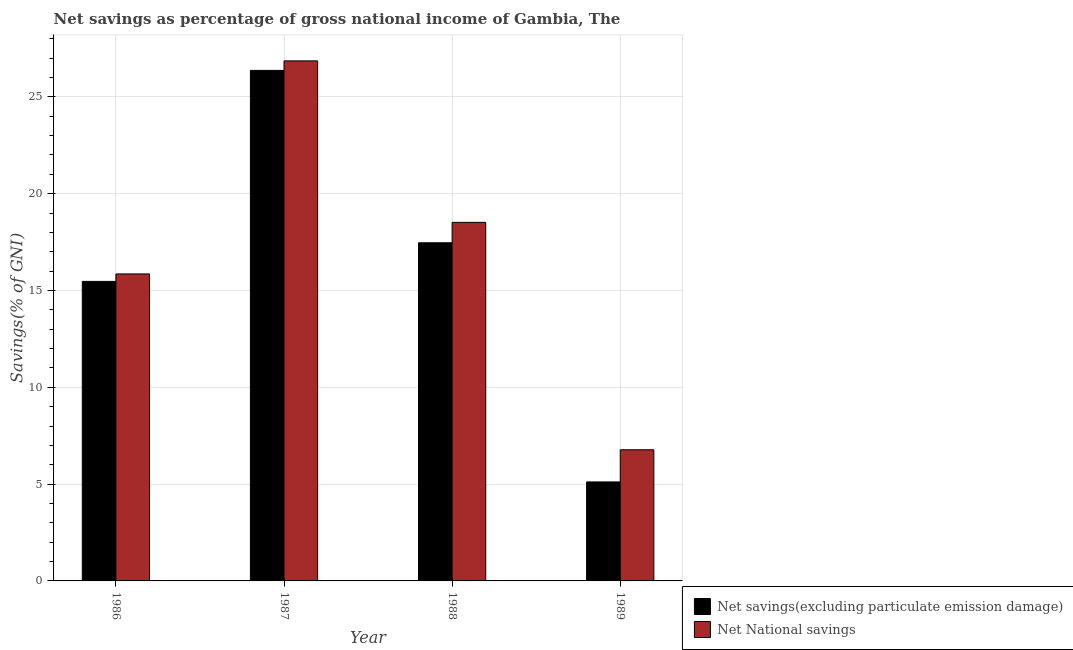Are the number of bars per tick equal to the number of legend labels?
Provide a short and direct response. Yes. Are the number of bars on each tick of the X-axis equal?
Give a very brief answer. Yes. How many bars are there on the 3rd tick from the right?
Offer a very short reply. 2. What is the net national savings in 1986?
Provide a succinct answer. 15.86. Across all years, what is the maximum net national savings?
Your response must be concise. 26.86. Across all years, what is the minimum net national savings?
Your answer should be compact. 6.77. In which year was the net national savings maximum?
Provide a succinct answer. 1987. In which year was the net national savings minimum?
Ensure brevity in your answer.  1989. What is the total net savings(excluding particulate emission damage) in the graph?
Your answer should be compact. 64.41. What is the difference between the net savings(excluding particulate emission damage) in 1986 and that in 1987?
Offer a terse response. -10.9. What is the difference between the net national savings in 1988 and the net savings(excluding particulate emission damage) in 1986?
Provide a short and direct response. 2.66. What is the average net savings(excluding particulate emission damage) per year?
Provide a succinct answer. 16.1. In the year 1989, what is the difference between the net savings(excluding particulate emission damage) and net national savings?
Provide a short and direct response. 0. In how many years, is the net national savings greater than 19 %?
Keep it short and to the point. 1. What is the ratio of the net national savings in 1988 to that in 1989?
Offer a terse response. 2.73. Is the net national savings in 1987 less than that in 1988?
Your answer should be very brief. No. What is the difference between the highest and the second highest net savings(excluding particulate emission damage)?
Give a very brief answer. 8.9. What is the difference between the highest and the lowest net national savings?
Offer a very short reply. 20.08. In how many years, is the net national savings greater than the average net national savings taken over all years?
Provide a succinct answer. 2. Is the sum of the net savings(excluding particulate emission damage) in 1988 and 1989 greater than the maximum net national savings across all years?
Provide a succinct answer. No. What does the 1st bar from the left in 1988 represents?
Give a very brief answer. Net savings(excluding particulate emission damage). What does the 1st bar from the right in 1987 represents?
Give a very brief answer. Net National savings. Are all the bars in the graph horizontal?
Ensure brevity in your answer.  No. Does the graph contain any zero values?
Give a very brief answer. No. Does the graph contain grids?
Ensure brevity in your answer.  Yes. Where does the legend appear in the graph?
Make the answer very short. Bottom right. How are the legend labels stacked?
Keep it short and to the point. Vertical. What is the title of the graph?
Ensure brevity in your answer.  Net savings as percentage of gross national income of Gambia, The. Does "Male labor force" appear as one of the legend labels in the graph?
Provide a short and direct response. No. What is the label or title of the X-axis?
Make the answer very short. Year. What is the label or title of the Y-axis?
Offer a terse response. Savings(% of GNI). What is the Savings(% of GNI) of Net savings(excluding particulate emission damage) in 1986?
Your response must be concise. 15.47. What is the Savings(% of GNI) of Net National savings in 1986?
Keep it short and to the point. 15.86. What is the Savings(% of GNI) in Net savings(excluding particulate emission damage) in 1987?
Give a very brief answer. 26.37. What is the Savings(% of GNI) in Net National savings in 1987?
Your response must be concise. 26.86. What is the Savings(% of GNI) of Net savings(excluding particulate emission damage) in 1988?
Your answer should be compact. 17.46. What is the Savings(% of GNI) of Net National savings in 1988?
Offer a very short reply. 18.52. What is the Savings(% of GNI) of Net savings(excluding particulate emission damage) in 1989?
Provide a succinct answer. 5.11. What is the Savings(% of GNI) in Net National savings in 1989?
Your answer should be very brief. 6.77. Across all years, what is the maximum Savings(% of GNI) of Net savings(excluding particulate emission damage)?
Your answer should be very brief. 26.37. Across all years, what is the maximum Savings(% of GNI) in Net National savings?
Offer a terse response. 26.86. Across all years, what is the minimum Savings(% of GNI) of Net savings(excluding particulate emission damage)?
Your answer should be compact. 5.11. Across all years, what is the minimum Savings(% of GNI) of Net National savings?
Your answer should be very brief. 6.77. What is the total Savings(% of GNI) of Net savings(excluding particulate emission damage) in the graph?
Make the answer very short. 64.41. What is the total Savings(% of GNI) in Net National savings in the graph?
Ensure brevity in your answer.  68.01. What is the difference between the Savings(% of GNI) of Net savings(excluding particulate emission damage) in 1986 and that in 1987?
Provide a short and direct response. -10.9. What is the difference between the Savings(% of GNI) of Net National savings in 1986 and that in 1987?
Provide a succinct answer. -11. What is the difference between the Savings(% of GNI) of Net savings(excluding particulate emission damage) in 1986 and that in 1988?
Provide a short and direct response. -1.99. What is the difference between the Savings(% of GNI) in Net National savings in 1986 and that in 1988?
Make the answer very short. -2.66. What is the difference between the Savings(% of GNI) in Net savings(excluding particulate emission damage) in 1986 and that in 1989?
Ensure brevity in your answer.  10.36. What is the difference between the Savings(% of GNI) of Net National savings in 1986 and that in 1989?
Your answer should be very brief. 9.08. What is the difference between the Savings(% of GNI) of Net savings(excluding particulate emission damage) in 1987 and that in 1988?
Make the answer very short. 8.9. What is the difference between the Savings(% of GNI) of Net National savings in 1987 and that in 1988?
Provide a succinct answer. 8.34. What is the difference between the Savings(% of GNI) in Net savings(excluding particulate emission damage) in 1987 and that in 1989?
Offer a very short reply. 21.26. What is the difference between the Savings(% of GNI) of Net National savings in 1987 and that in 1989?
Make the answer very short. 20.08. What is the difference between the Savings(% of GNI) of Net savings(excluding particulate emission damage) in 1988 and that in 1989?
Your answer should be compact. 12.35. What is the difference between the Savings(% of GNI) in Net National savings in 1988 and that in 1989?
Keep it short and to the point. 11.74. What is the difference between the Savings(% of GNI) in Net savings(excluding particulate emission damage) in 1986 and the Savings(% of GNI) in Net National savings in 1987?
Make the answer very short. -11.39. What is the difference between the Savings(% of GNI) of Net savings(excluding particulate emission damage) in 1986 and the Savings(% of GNI) of Net National savings in 1988?
Ensure brevity in your answer.  -3.05. What is the difference between the Savings(% of GNI) in Net savings(excluding particulate emission damage) in 1986 and the Savings(% of GNI) in Net National savings in 1989?
Offer a very short reply. 8.7. What is the difference between the Savings(% of GNI) in Net savings(excluding particulate emission damage) in 1987 and the Savings(% of GNI) in Net National savings in 1988?
Give a very brief answer. 7.85. What is the difference between the Savings(% of GNI) in Net savings(excluding particulate emission damage) in 1987 and the Savings(% of GNI) in Net National savings in 1989?
Your response must be concise. 19.59. What is the difference between the Savings(% of GNI) of Net savings(excluding particulate emission damage) in 1988 and the Savings(% of GNI) of Net National savings in 1989?
Ensure brevity in your answer.  10.69. What is the average Savings(% of GNI) of Net savings(excluding particulate emission damage) per year?
Make the answer very short. 16.1. What is the average Savings(% of GNI) in Net National savings per year?
Provide a succinct answer. 17. In the year 1986, what is the difference between the Savings(% of GNI) in Net savings(excluding particulate emission damage) and Savings(% of GNI) in Net National savings?
Make the answer very short. -0.39. In the year 1987, what is the difference between the Savings(% of GNI) of Net savings(excluding particulate emission damage) and Savings(% of GNI) of Net National savings?
Offer a very short reply. -0.49. In the year 1988, what is the difference between the Savings(% of GNI) in Net savings(excluding particulate emission damage) and Savings(% of GNI) in Net National savings?
Make the answer very short. -1.05. In the year 1989, what is the difference between the Savings(% of GNI) in Net savings(excluding particulate emission damage) and Savings(% of GNI) in Net National savings?
Make the answer very short. -1.66. What is the ratio of the Savings(% of GNI) in Net savings(excluding particulate emission damage) in 1986 to that in 1987?
Your response must be concise. 0.59. What is the ratio of the Savings(% of GNI) in Net National savings in 1986 to that in 1987?
Keep it short and to the point. 0.59. What is the ratio of the Savings(% of GNI) of Net savings(excluding particulate emission damage) in 1986 to that in 1988?
Offer a terse response. 0.89. What is the ratio of the Savings(% of GNI) of Net National savings in 1986 to that in 1988?
Make the answer very short. 0.86. What is the ratio of the Savings(% of GNI) in Net savings(excluding particulate emission damage) in 1986 to that in 1989?
Offer a terse response. 3.03. What is the ratio of the Savings(% of GNI) of Net National savings in 1986 to that in 1989?
Ensure brevity in your answer.  2.34. What is the ratio of the Savings(% of GNI) of Net savings(excluding particulate emission damage) in 1987 to that in 1988?
Keep it short and to the point. 1.51. What is the ratio of the Savings(% of GNI) in Net National savings in 1987 to that in 1988?
Offer a very short reply. 1.45. What is the ratio of the Savings(% of GNI) of Net savings(excluding particulate emission damage) in 1987 to that in 1989?
Provide a succinct answer. 5.16. What is the ratio of the Savings(% of GNI) of Net National savings in 1987 to that in 1989?
Offer a very short reply. 3.97. What is the ratio of the Savings(% of GNI) in Net savings(excluding particulate emission damage) in 1988 to that in 1989?
Make the answer very short. 3.42. What is the ratio of the Savings(% of GNI) of Net National savings in 1988 to that in 1989?
Your answer should be compact. 2.73. What is the difference between the highest and the second highest Savings(% of GNI) of Net savings(excluding particulate emission damage)?
Your answer should be very brief. 8.9. What is the difference between the highest and the second highest Savings(% of GNI) of Net National savings?
Make the answer very short. 8.34. What is the difference between the highest and the lowest Savings(% of GNI) of Net savings(excluding particulate emission damage)?
Keep it short and to the point. 21.26. What is the difference between the highest and the lowest Savings(% of GNI) of Net National savings?
Make the answer very short. 20.08. 